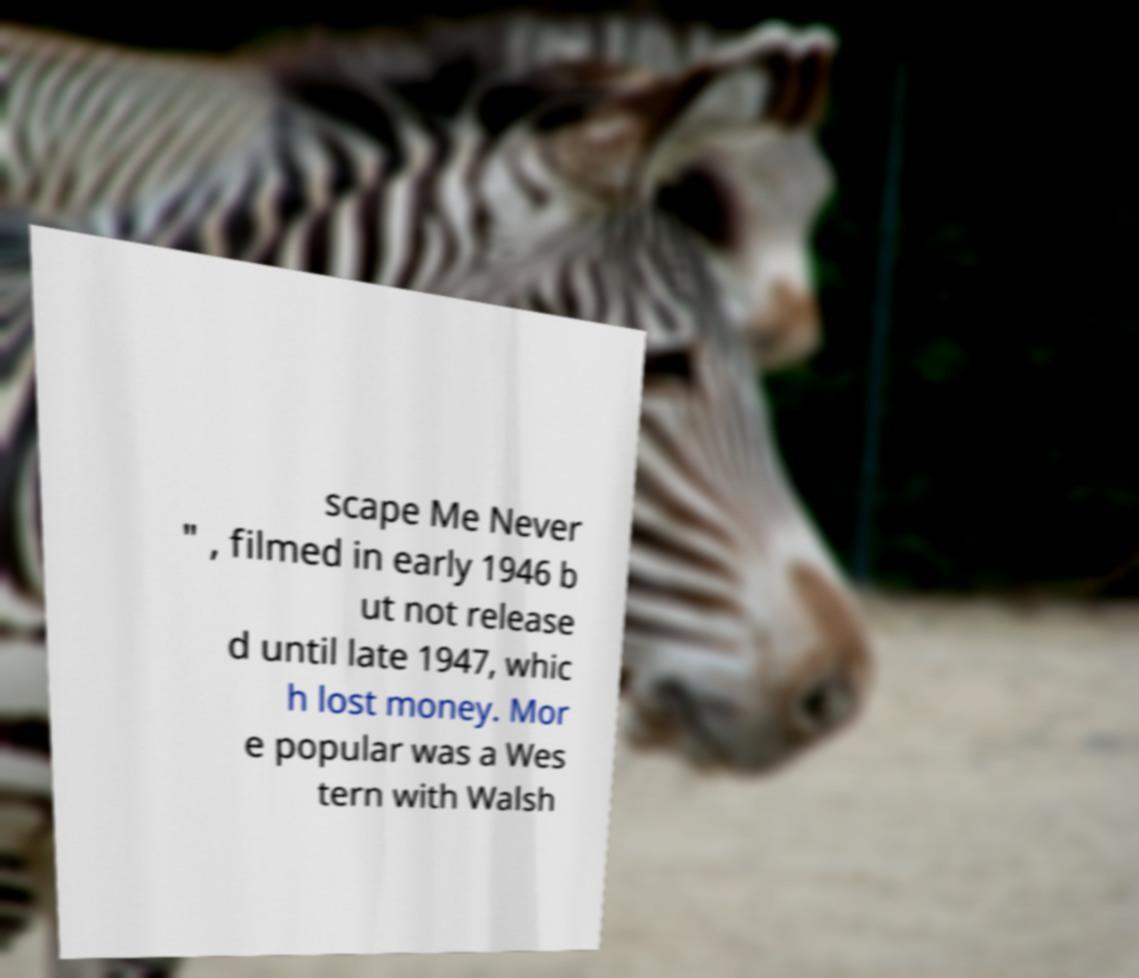Can you read and provide the text displayed in the image?This photo seems to have some interesting text. Can you extract and type it out for me? scape Me Never " , filmed in early 1946 b ut not release d until late 1947, whic h lost money. Mor e popular was a Wes tern with Walsh 